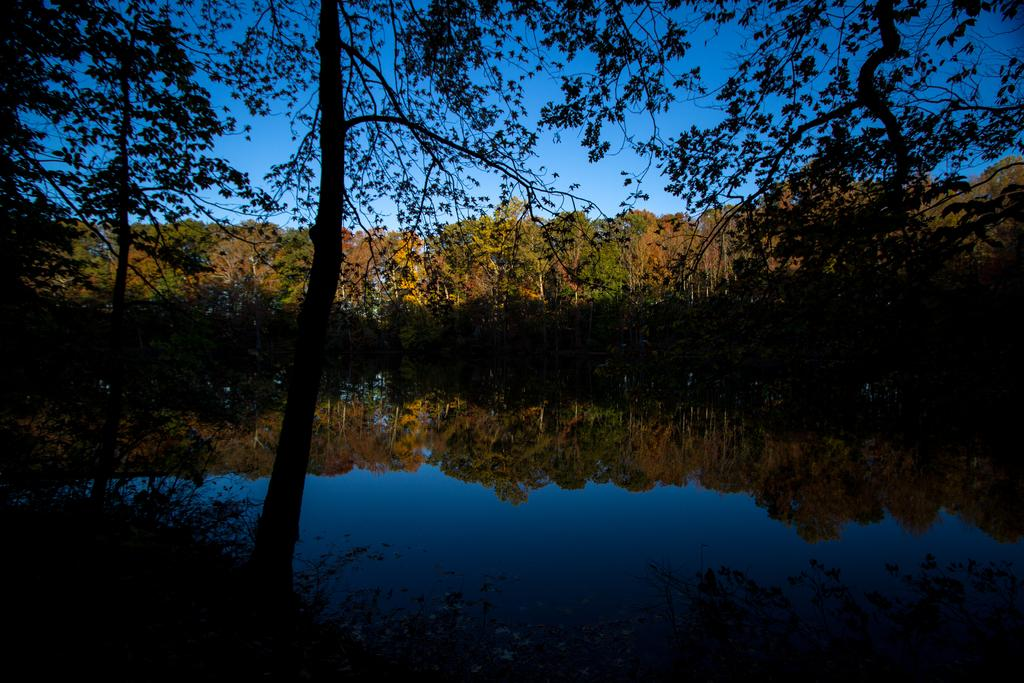What type of natural feature is at the bottom of the image? There is a river at the bottom of the image. What can be found near the river? There are plants near the river. What is visible in the background of the image? There are trees in the background of the image. What is visible at the top of the image? The sky is visible at the top of the image. What type of shirt is being worn by the tree in the image? There are no shirts or people present in the image, as it features a river, plants, trees, and the sky. 